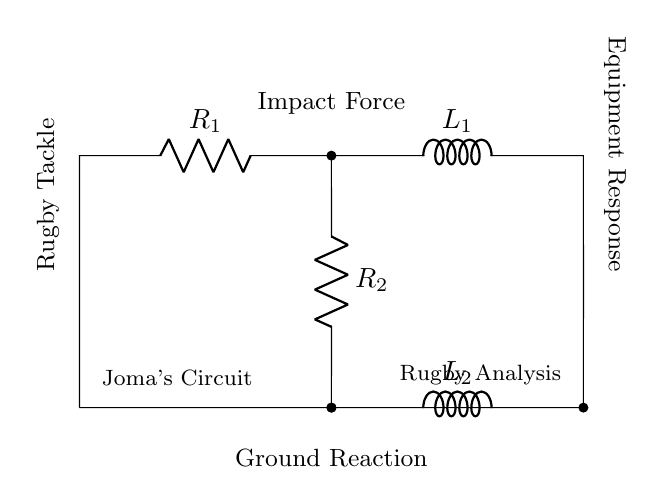What are the resistors present in this circuit? The circuit includes two resistors labeled R1 and R2.
Answer: R1, R2 What is the total current flowing through R1 in a series configuration? Since R1 is in series with L1 and we assume a single current path, the same current that flows through R1 also flows through L1. Therefore, the current through R1 is the total current through the series circuit.
Answer: Total current What does the variable L1 represent in this circuit? In this circuit, L1 represents an inductor component which stores energy in a magnetic field when current flows through it.
Answer: Inductor How are R2 and L2 connected in the circuit? R2 and L2 are connected in parallel with each other, as they have nodes that connect them directly to the same points in the circuit.
Answer: Parallel If the impact force changes, how might that affect the response of the equipment? A change in impact force will influence the current flowing through the circuit, affecting the magnetic field in L1 and L2, resulting in different voltage levels across components, thus modifying how the rugby equipment responds.
Answer: Equipment response changes What effect does L2 have on the circuit dynamics compared to R2? L2 will introduce a time-dependent behavior (due to inductance) that R2 does not have; R2 offers resistive impedance, while L2 affects the transient response of the circuit.
Answer: Time-dependent behavior 